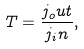<formula> <loc_0><loc_0><loc_500><loc_500>T = \frac { j _ { o } u t } { j _ { i } n } ,</formula> 